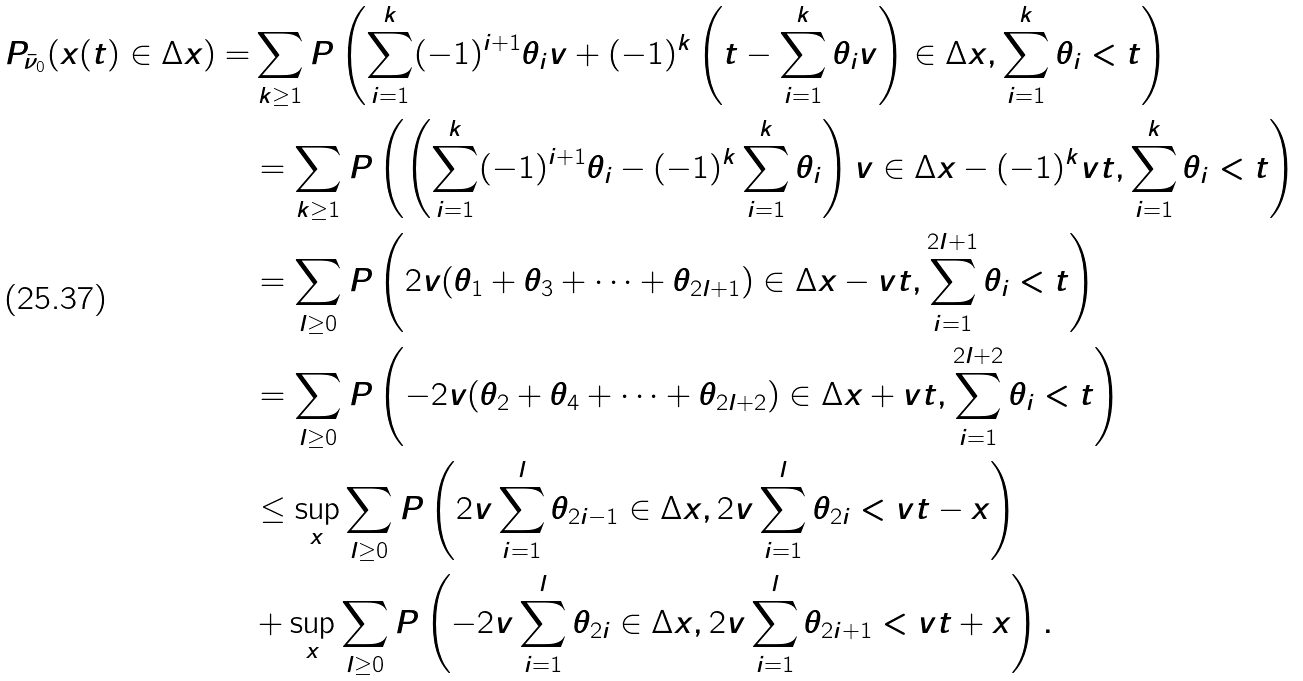Convert formula to latex. <formula><loc_0><loc_0><loc_500><loc_500>P _ { \bar { \nu } _ { 0 } } ( x ( t ) \in \Delta x ) = & \sum _ { k \geq 1 } P \left ( \sum _ { i = 1 } ^ { k } ( - 1 ) ^ { i + 1 } \theta _ { i } v + ( - 1 ) ^ { k } \left ( t - \sum _ { i = 1 } ^ { k } \theta _ { i } v \right ) \in \Delta x , \sum _ { i = 1 } ^ { k } \theta _ { i } < t \right ) \\ & = \sum _ { k \geq 1 } P \left ( \left ( \sum _ { i = 1 } ^ { k } ( - 1 ) ^ { i + 1 } \theta _ { i } - ( - 1 ) ^ { k } \sum _ { i = 1 } ^ { k } \theta _ { i } \right ) v \in \Delta x - ( - 1 ) ^ { k } v t , \sum _ { i = 1 } ^ { k } \theta _ { i } < t \right ) \\ & = \sum _ { l \geq 0 } P \left ( 2 v ( \theta _ { 1 } + \theta _ { 3 } + \dots + \theta _ { 2 l + 1 } ) \in \Delta x - v t , \sum _ { i = 1 } ^ { 2 l + 1 } \theta _ { i } < t \right ) \\ & = \sum _ { l \geq 0 } P \left ( - 2 v ( \theta _ { 2 } + \theta _ { 4 } + \dots + \theta _ { 2 l + 2 } ) \in \Delta x + v t , \sum _ { i = 1 } ^ { 2 l + 2 } \theta _ { i } < t \right ) \\ & \leq \sup _ { x } \sum _ { l \geq 0 } P \left ( 2 v \sum _ { i = 1 } ^ { l } \theta _ { 2 i - 1 } \in \Delta x , 2 v \sum _ { i = 1 } ^ { l } \theta _ { 2 i } < v t - x \right ) \\ & + \sup _ { x } \sum _ { l \geq 0 } P \left ( - 2 v \sum _ { i = 1 } ^ { l } \theta _ { 2 i } \in \Delta x , 2 v \sum _ { i = 1 } ^ { l } \theta _ { 2 i + 1 } < v t + x \right ) .</formula> 